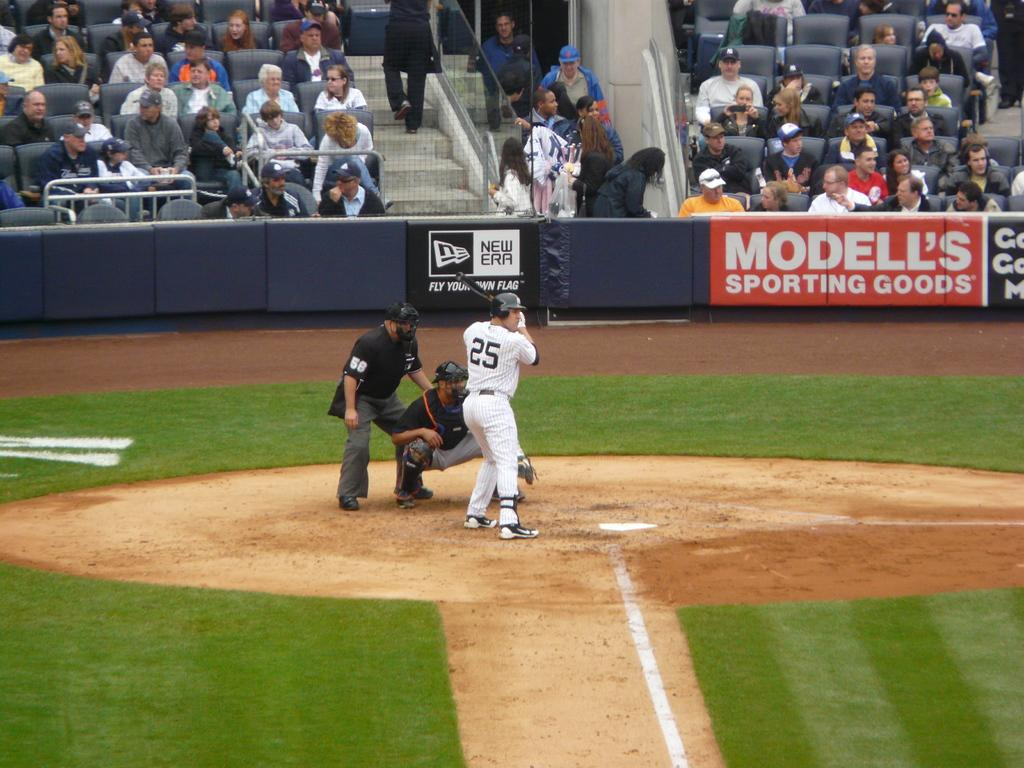<image>
Present a compact description of the photo's key features. A Modell's Sporting Goods banner hangs off the stands as fans enjoy a baseball game. 